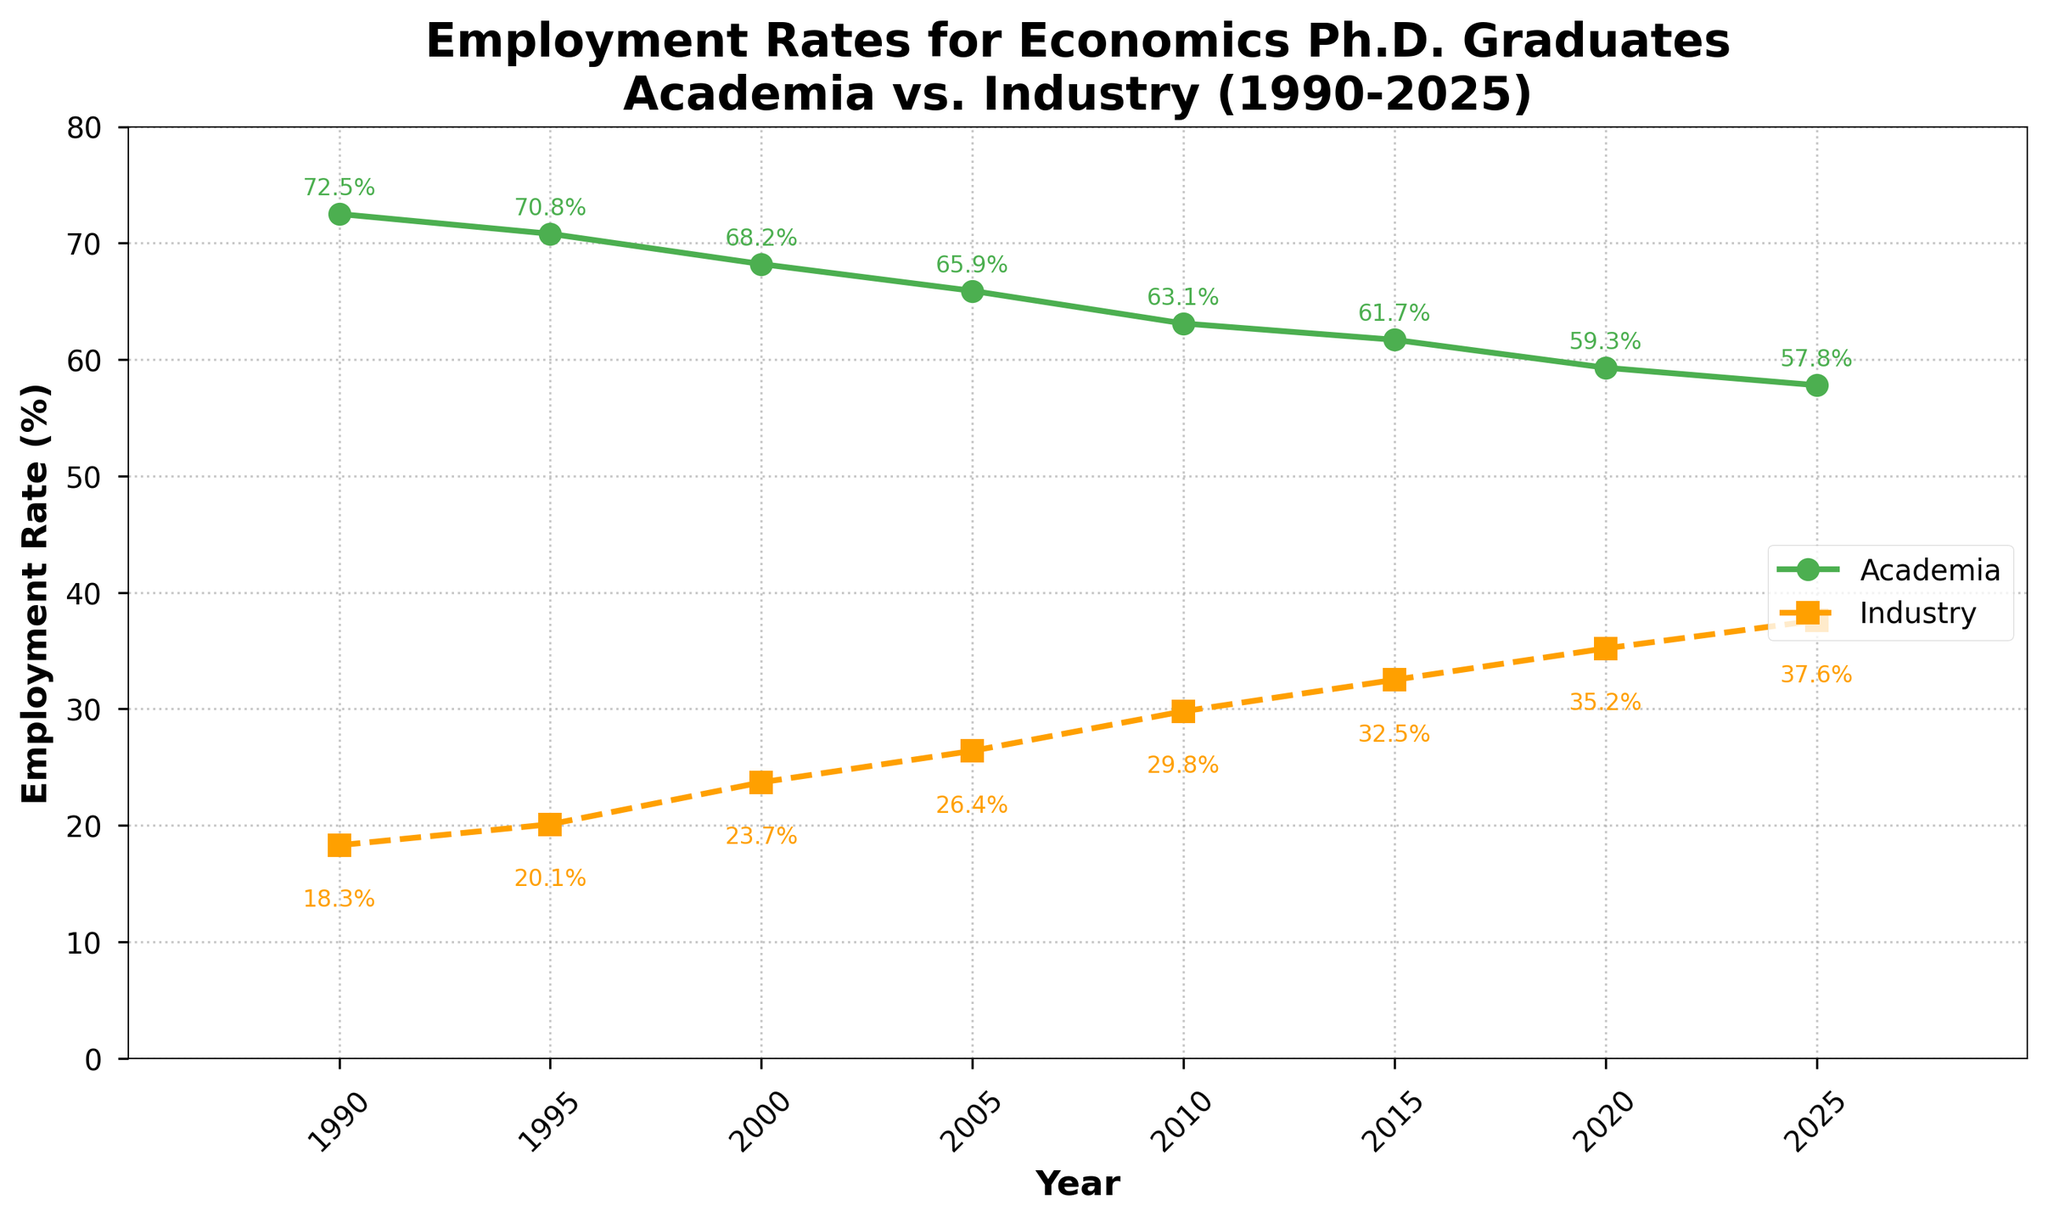What is the employment rate for economics Ph.D. graduates in academia in 2005? The figure shows a line for academia employment rates. In 2005, the rate is labeled at 65.9%.
Answer: 65.9% How much did the industry employment rate change from 1990 to 2025? The figure shows the industry employment rate increasing from 18.3% in 1990 to 37.6% in 2025. The change is 37.6% - 18.3%.
Answer: 19.3% Which year shows the smallest difference between academia and industry employment rates? Observing the separation between the Academia and Industry lines, 2025 shows the smallest difference visually. Subtracting rates in 2025, we get 57.8% - 37.6%.
Answer: 2025 How many years show an employment rate in academia below 70%? The academia line crosses below 70% around 2000 and remains there for subsequent years. Starting from 2000, the count of years below 70% is 6: 2000, 2005, 2010, 2015, 2020, 2025
Answer: 6 What is the average academia employment rate for the years 1990, 2000, and 2010? The rates are 72.5% in 1990, 68.2% in 2000, and 63.1% in 2010. Adding these and dividing by 3 gives (72.5 + 68.2 + 63.1) / 3.
Answer: 67.93% 